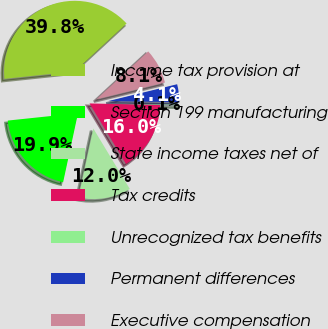Convert chart to OTSL. <chart><loc_0><loc_0><loc_500><loc_500><pie_chart><fcel>Income tax provision at<fcel>Section 199 manufacturing<fcel>State income taxes net of<fcel>Tax credits<fcel>Unrecognized tax benefits<fcel>Permanent differences<fcel>Executive compensation<nl><fcel>39.8%<fcel>19.95%<fcel>12.02%<fcel>15.99%<fcel>0.11%<fcel>4.08%<fcel>8.05%<nl></chart> 